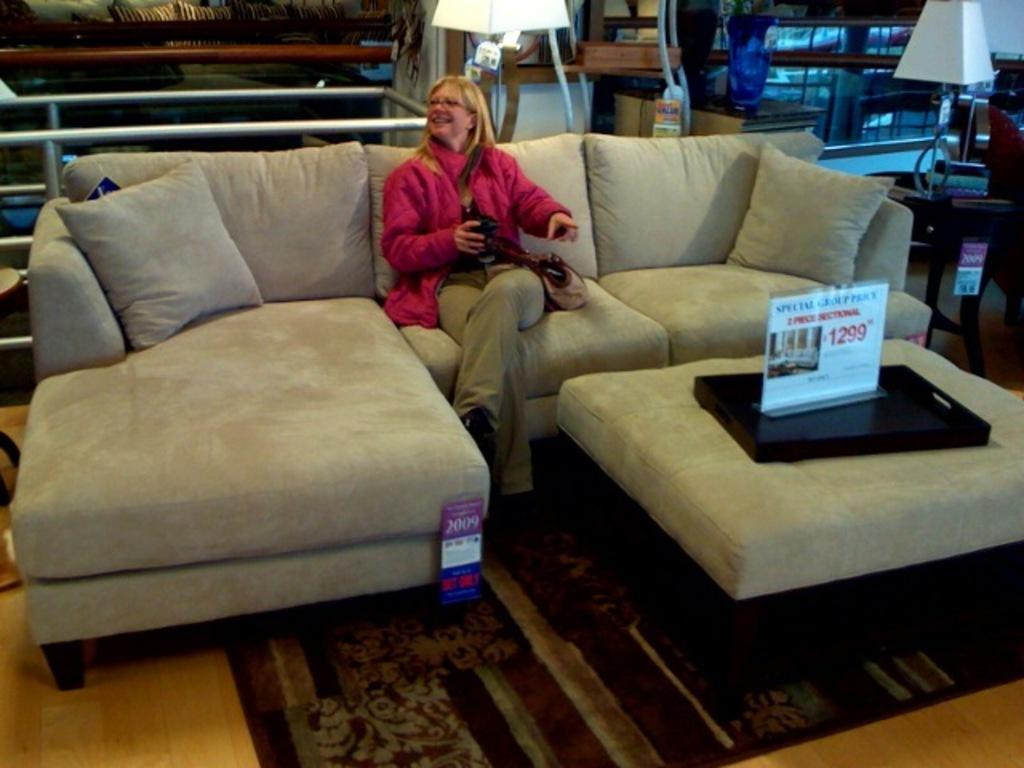Could you give a brief overview of what you see in this image? This picture is of inside the room. On the right there is a center table on the top of which a paper and a tray is placed. In the right corner there is a lamp placed on the top of the table. In the center there is a woman smiling and sitting on the couch and in the foreground we can see floor covered with a carpet. In the background there is a lamp and another couch. 